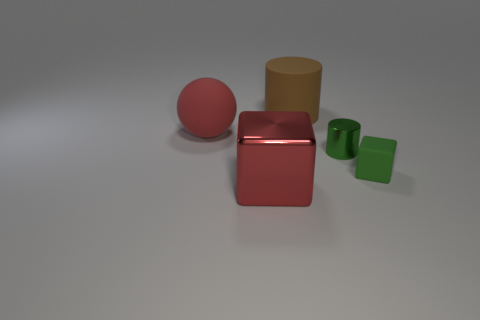How many shiny things are the same color as the small rubber object?
Give a very brief answer. 1. There is a matte ball that is the same color as the large shiny thing; what is its size?
Provide a short and direct response. Large. What is the large cube made of?
Your response must be concise. Metal. There is a thing that is behind the tiny green rubber object and to the right of the big brown rubber cylinder; what material is it?
Your answer should be compact. Metal. What number of things are either big things that are behind the green cube or tiny blue objects?
Your answer should be compact. 2. Is the color of the metallic cylinder the same as the large cube?
Keep it short and to the point. No. Is there a red rubber cylinder of the same size as the brown thing?
Your response must be concise. No. How many matte things are right of the red shiny block and behind the tiny green block?
Keep it short and to the point. 1. There is a brown rubber cylinder; what number of tiny things are behind it?
Ensure brevity in your answer.  0. Are there any other green objects that have the same shape as the green rubber thing?
Make the answer very short. No. 